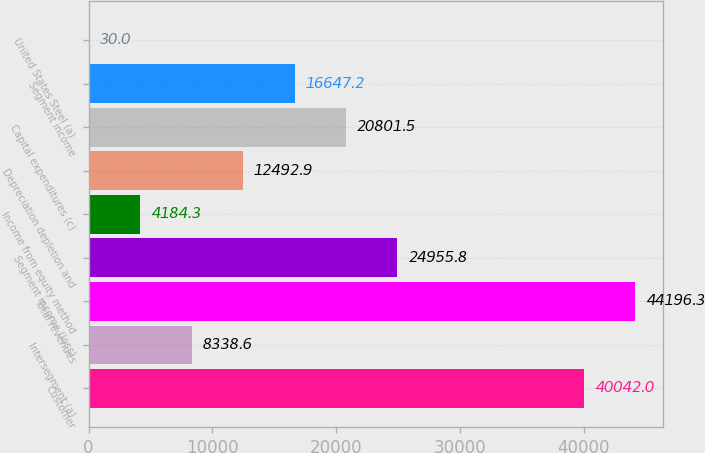Convert chart. <chart><loc_0><loc_0><loc_500><loc_500><bar_chart><fcel>Customer<fcel>Intersegment (a)<fcel>Total revenues<fcel>Segment income (loss)<fcel>Income from equity method<fcel>Depreciation depletion and<fcel>Capital expenditures (c)<fcel>Segment income<fcel>United States Steel (a)<nl><fcel>40042<fcel>8338.6<fcel>44196.3<fcel>24955.8<fcel>4184.3<fcel>12492.9<fcel>20801.5<fcel>16647.2<fcel>30<nl></chart> 